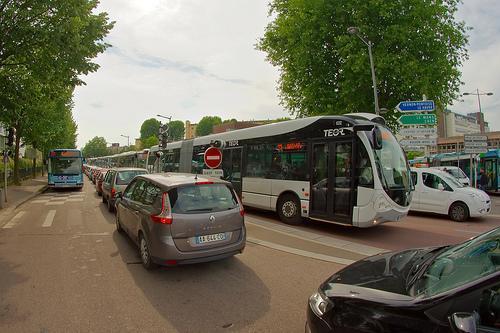How many buses are shown?
Give a very brief answer. 2. 